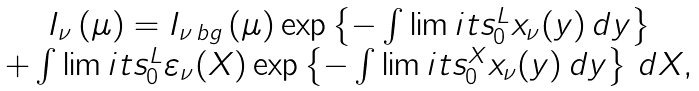Convert formula to latex. <formula><loc_0><loc_0><loc_500><loc_500>\begin{array} { c } I _ { \nu } \left ( \mu \right ) = I _ { \nu \, b g } \left ( \mu \right ) \exp \left \{ - \int \lim i t s _ { 0 } ^ { L } x _ { \nu } ( y ) \, d y \right \} \\ + \int \lim i t s _ { 0 } ^ { L } \varepsilon _ { \nu } ( X ) \exp \left \{ - \int \lim i t s _ { 0 } ^ { X } x _ { \nu } ( y ) \, d y \right \} \, d X , \\ \end{array}</formula> 